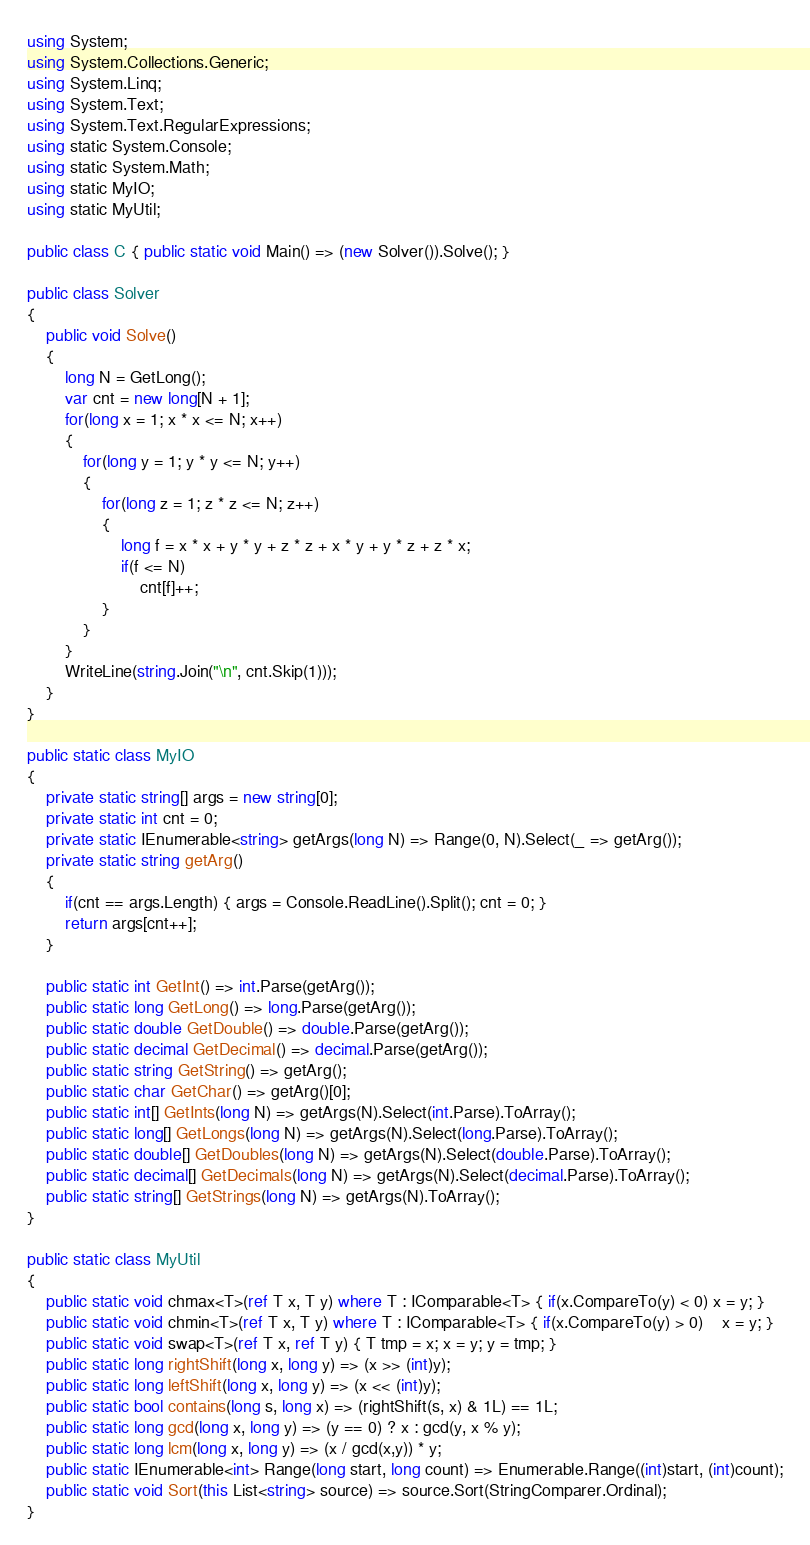Convert code to text. <code><loc_0><loc_0><loc_500><loc_500><_C#_>using System;
using System.Collections.Generic;
using System.Linq;
using System.Text;
using System.Text.RegularExpressions;
using static System.Console;
using static System.Math;
using static MyIO;
using static MyUtil;

public class C { public static void Main() => (new Solver()).Solve(); }

public class Solver
{
	public void Solve()
	{
		long N = GetLong();
		var cnt = new long[N + 1];
		for(long x = 1; x * x <= N; x++)
		{
			for(long y = 1; y * y <= N; y++)
			{
				for(long z = 1; z * z <= N; z++)
				{
					long f = x * x + y * y + z * z + x * y + y * z + z * x;
					if(f <= N)
						cnt[f]++;
				}
			}
		}
		WriteLine(string.Join("\n", cnt.Skip(1)));
	}
}

public static class MyIO
{
	private static string[] args = new string[0];
	private static int cnt = 0;
	private static IEnumerable<string> getArgs(long N) => Range(0, N).Select(_ => getArg());
	private static string getArg()
	{
		if(cnt == args.Length) { args = Console.ReadLine().Split(); cnt = 0; }
		return args[cnt++];
	}

	public static int GetInt() => int.Parse(getArg());
	public static long GetLong() => long.Parse(getArg());
	public static double GetDouble() => double.Parse(getArg());
	public static decimal GetDecimal() => decimal.Parse(getArg());
	public static string GetString() => getArg();
	public static char GetChar() => getArg()[0];
	public static int[] GetInts(long N) => getArgs(N).Select(int.Parse).ToArray();
	public static long[] GetLongs(long N) => getArgs(N).Select(long.Parse).ToArray();
	public static double[] GetDoubles(long N) => getArgs(N).Select(double.Parse).ToArray();
	public static decimal[] GetDecimals(long N) => getArgs(N).Select(decimal.Parse).ToArray();
	public static string[] GetStrings(long N) => getArgs(N).ToArray();
}

public static class MyUtil
{
	public static void chmax<T>(ref T x, T y) where T : IComparable<T> { if(x.CompareTo(y) < 0) x = y; }
	public static void chmin<T>(ref T x, T y) where T : IComparable<T> { if(x.CompareTo(y) > 0)	x = y; }
	public static void swap<T>(ref T x, ref T y) { T tmp = x; x = y; y = tmp; }
	public static long rightShift(long x, long y) => (x >> (int)y);
	public static long leftShift(long x, long y) => (x << (int)y);
	public static bool contains(long s, long x) => (rightShift(s, x) & 1L) == 1L;
	public static long gcd(long x, long y) => (y == 0) ? x : gcd(y, x % y);
	public static long lcm(long x, long y) => (x / gcd(x,y)) * y;	
	public static IEnumerable<int> Range(long start, long count) => Enumerable.Range((int)start, (int)count);
	public static void Sort(this List<string> source) => source.Sort(StringComparer.Ordinal);
}
</code> 